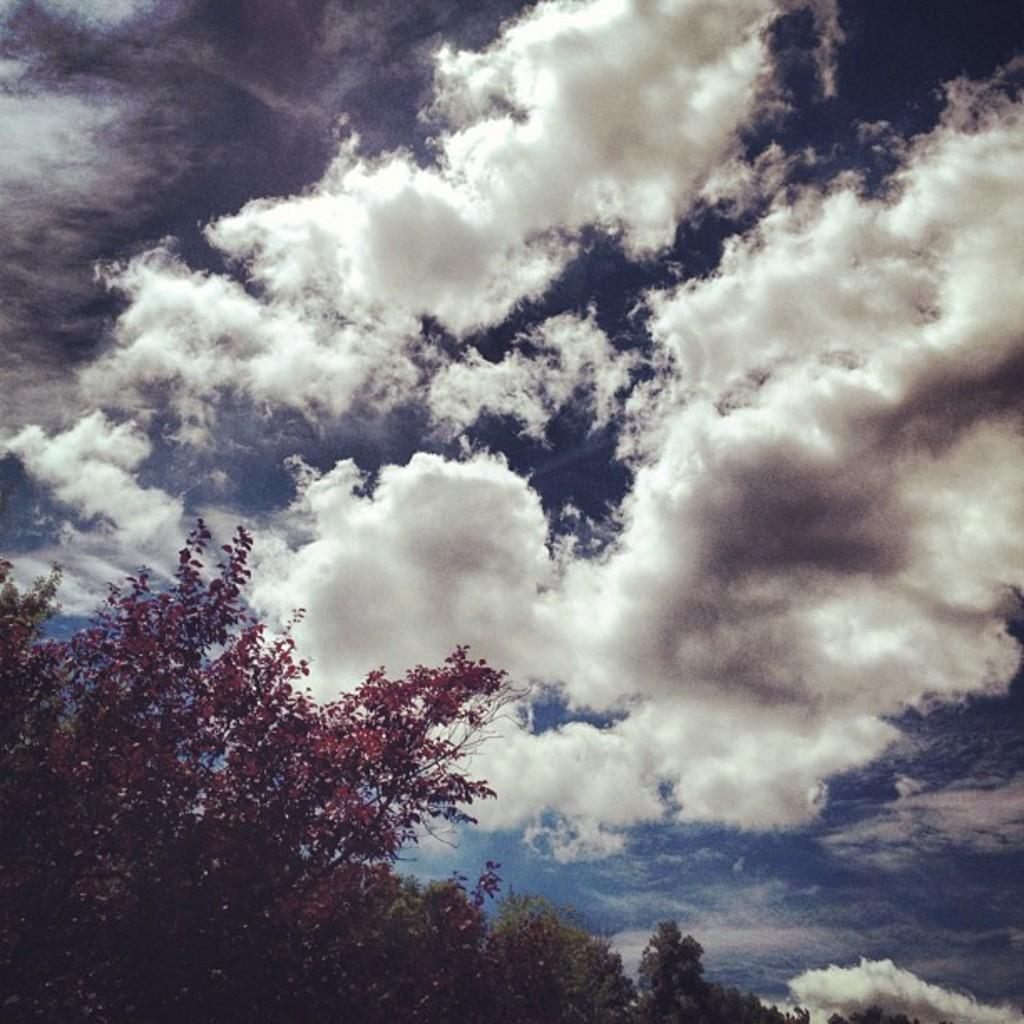What type of vegetation can be seen in the image? There are trees in the image. What can be seen in the sky in the image? There are clouds in the sky in the image. What type of leather is visible on the trees in the image? There is no leather present on the trees in the image; they are made of wood and foliage. What color is the pencil used to draw the clouds in the image? There is no pencil or drawing present in the image; the clouds are a natural part of the sky. 